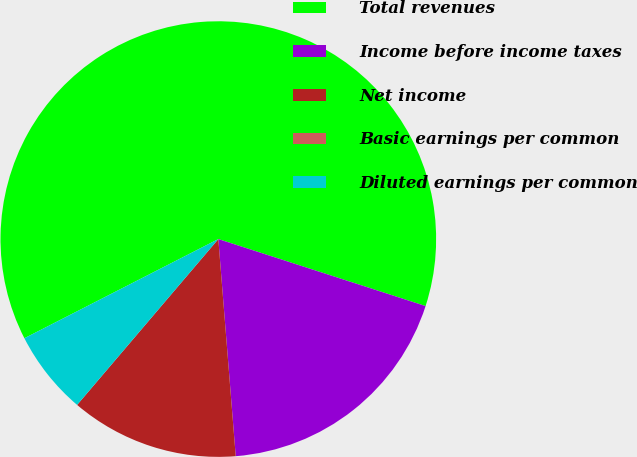<chart> <loc_0><loc_0><loc_500><loc_500><pie_chart><fcel>Total revenues<fcel>Income before income taxes<fcel>Net income<fcel>Basic earnings per common<fcel>Diluted earnings per common<nl><fcel>62.5%<fcel>18.75%<fcel>12.5%<fcel>0.0%<fcel>6.25%<nl></chart> 